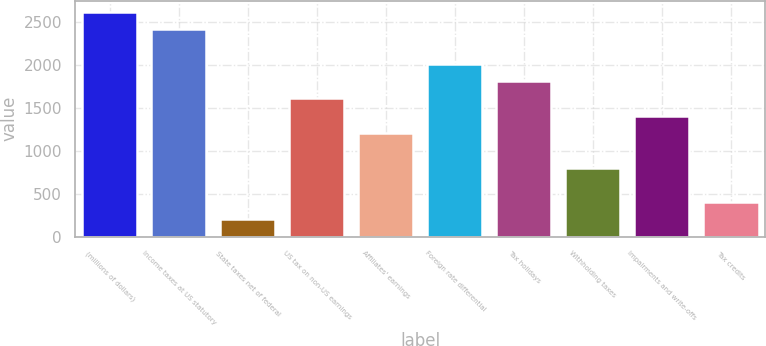Convert chart to OTSL. <chart><loc_0><loc_0><loc_500><loc_500><bar_chart><fcel>(millions of dollars)<fcel>Income taxes at US statutory<fcel>State taxes net of federal<fcel>US tax on non-US earnings<fcel>Affiliates' earnings<fcel>Foreign rate differential<fcel>Tax holidays<fcel>Withholding taxes<fcel>Impairments and write-offs<fcel>Tax credits<nl><fcel>2615.33<fcel>2414.22<fcel>202.01<fcel>1609.78<fcel>1207.56<fcel>2012<fcel>1810.89<fcel>805.34<fcel>1408.67<fcel>403.12<nl></chart> 